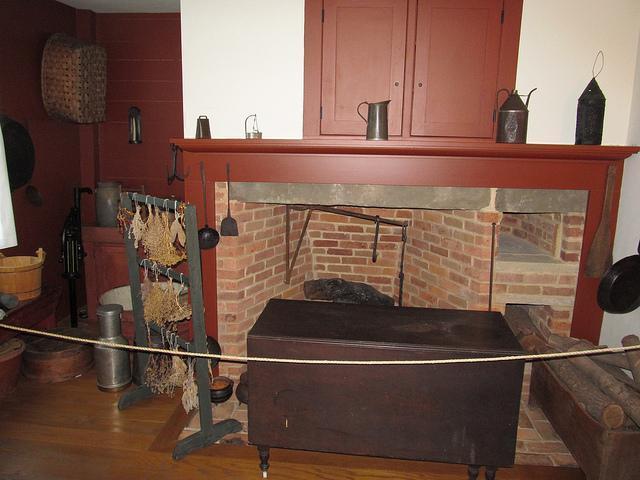Why is the area in the room roped off?
Select the accurate response from the four choices given to answer the question.
Options: Historical significance, wet paint, construction, crime scene. Historical significance. 